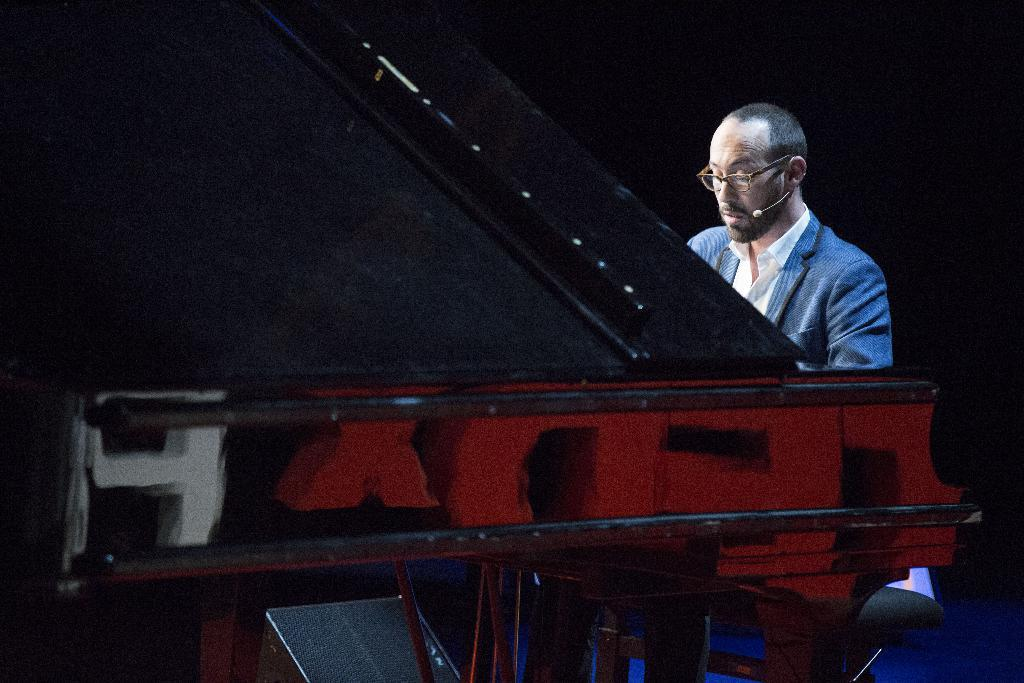Who is present in the image? There is a person in the image. What is the person wearing? The person is wearing a blue suit. What is the person doing in the image? The person is playing a musical instrument. What type of spark can be seen coming from the musical instrument in the image? There is no spark visible in the image; the person is simply playing a musical instrument. 